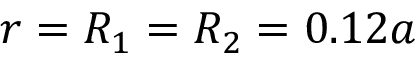<formula> <loc_0><loc_0><loc_500><loc_500>r = R _ { 1 } = R _ { 2 } = 0 . 1 2 a</formula> 